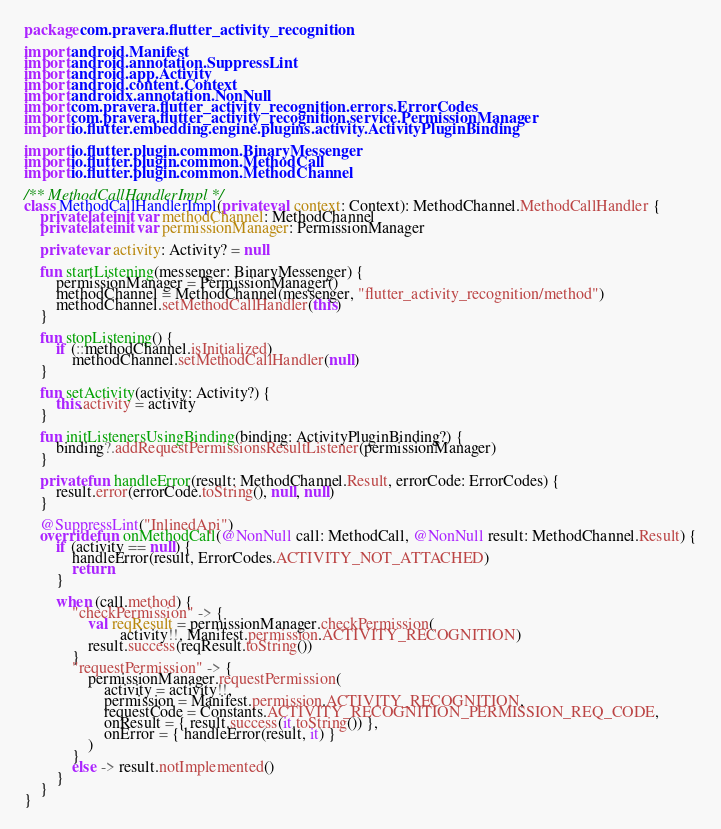<code> <loc_0><loc_0><loc_500><loc_500><_Kotlin_>package com.pravera.flutter_activity_recognition

import android.Manifest
import android.annotation.SuppressLint
import android.app.Activity
import android.content.Context
import androidx.annotation.NonNull
import com.pravera.flutter_activity_recognition.errors.ErrorCodes
import com.pravera.flutter_activity_recognition.service.PermissionManager
import io.flutter.embedding.engine.plugins.activity.ActivityPluginBinding

import io.flutter.plugin.common.BinaryMessenger
import io.flutter.plugin.common.MethodCall
import io.flutter.plugin.common.MethodChannel

/** MethodCallHandlerImpl */
class MethodCallHandlerImpl(private val context: Context): MethodChannel.MethodCallHandler {
	private lateinit var methodChannel: MethodChannel
	private lateinit var permissionManager: PermissionManager

	private var activity: Activity? = null

	fun startListening(messenger: BinaryMessenger) {
		permissionManager = PermissionManager()
		methodChannel = MethodChannel(messenger, "flutter_activity_recognition/method")
		methodChannel.setMethodCallHandler(this)
	}

	fun stopListening() {
		if (::methodChannel.isInitialized)
			methodChannel.setMethodCallHandler(null)
	}

	fun setActivity(activity: Activity?) {
		this.activity = activity
	}

	fun initListenersUsingBinding(binding: ActivityPluginBinding?) {
		binding?.addRequestPermissionsResultListener(permissionManager)
	}

	private fun handleError(result: MethodChannel.Result, errorCode: ErrorCodes) {
		result.error(errorCode.toString(), null, null)
	}

	@SuppressLint("InlinedApi")
	override fun onMethodCall(@NonNull call: MethodCall, @NonNull result: MethodChannel.Result) {
		if (activity == null) {
			handleError(result, ErrorCodes.ACTIVITY_NOT_ATTACHED)
			return
		}

		when (call.method) {
			"checkPermission" -> {
				val reqResult = permissionManager.checkPermission(
						activity!!, Manifest.permission.ACTIVITY_RECOGNITION)
				result.success(reqResult.toString())
			}
			"requestPermission" -> {
				permissionManager.requestPermission(
					activity = activity!!,
					permission = Manifest.permission.ACTIVITY_RECOGNITION,
					requestCode = Constants.ACTIVITY_RECOGNITION_PERMISSION_REQ_CODE,
					onResult = { result.success(it.toString()) },
					onError = { handleError(result, it) }
				)
			}
			else -> result.notImplemented()
		}
	}
}
</code> 